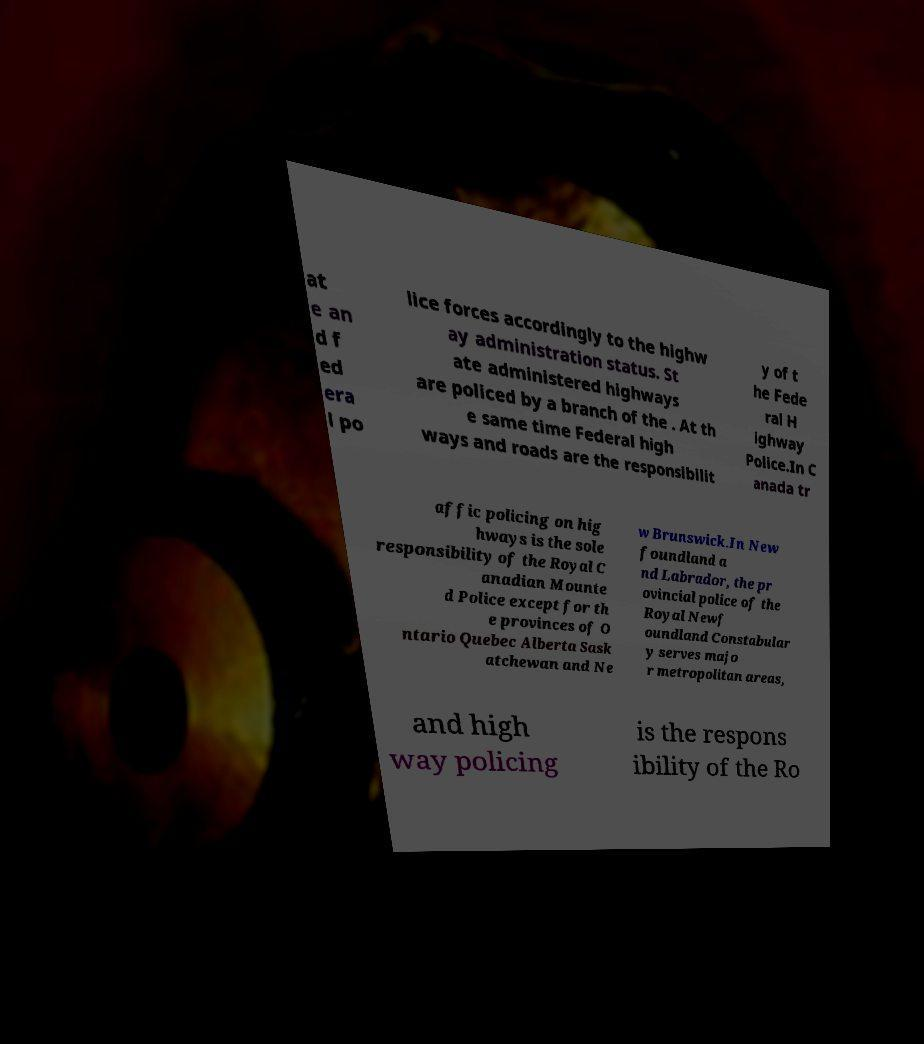Could you extract and type out the text from this image? at e an d f ed era l po lice forces accordingly to the highw ay administration status. St ate administered highways are policed by a branch of the . At th e same time Federal high ways and roads are the responsibilit y of t he Fede ral H ighway Police.In C anada tr affic policing on hig hways is the sole responsibility of the Royal C anadian Mounte d Police except for th e provinces of O ntario Quebec Alberta Sask atchewan and Ne w Brunswick.In New foundland a nd Labrador, the pr ovincial police of the Royal Newf oundland Constabular y serves majo r metropolitan areas, and high way policing is the respons ibility of the Ro 